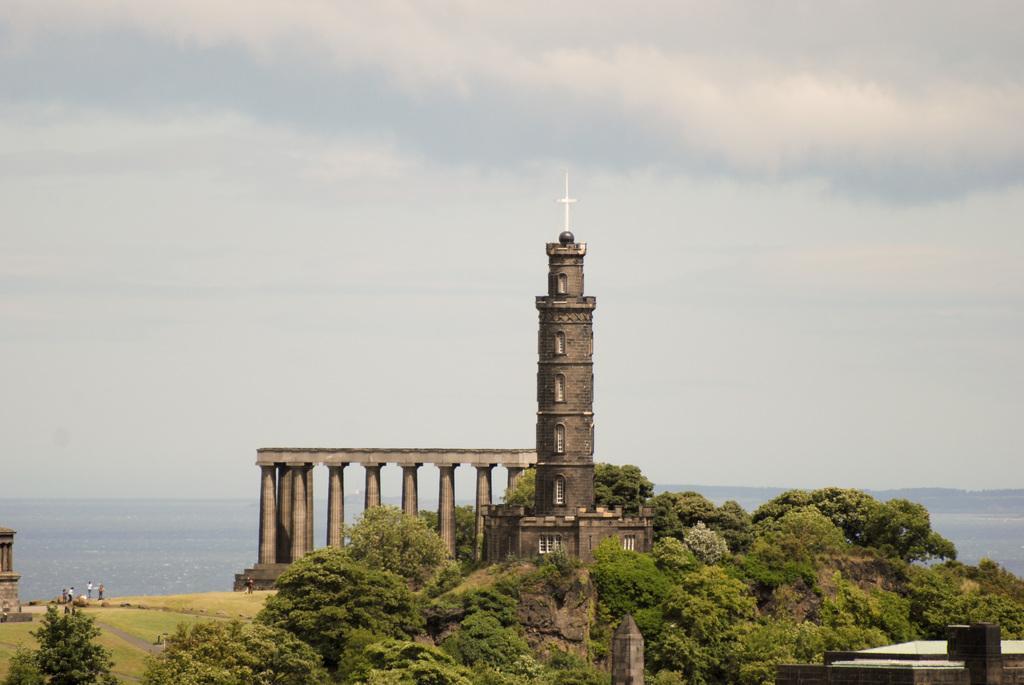Please provide a concise description of this image. In this picture I can see tower like building, side there are some pillories with roof, in front some people are on the grass, side there are some trees, behind I can see full of water. 